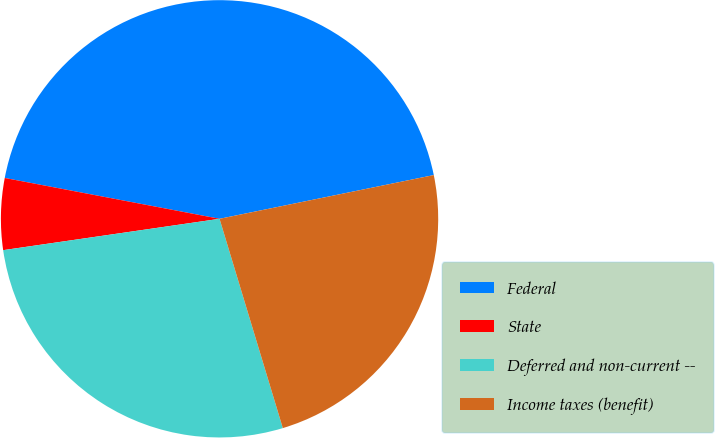<chart> <loc_0><loc_0><loc_500><loc_500><pie_chart><fcel>Federal<fcel>State<fcel>Deferred and non-current --<fcel>Income taxes (benefit)<nl><fcel>43.8%<fcel>5.28%<fcel>27.38%<fcel>23.53%<nl></chart> 